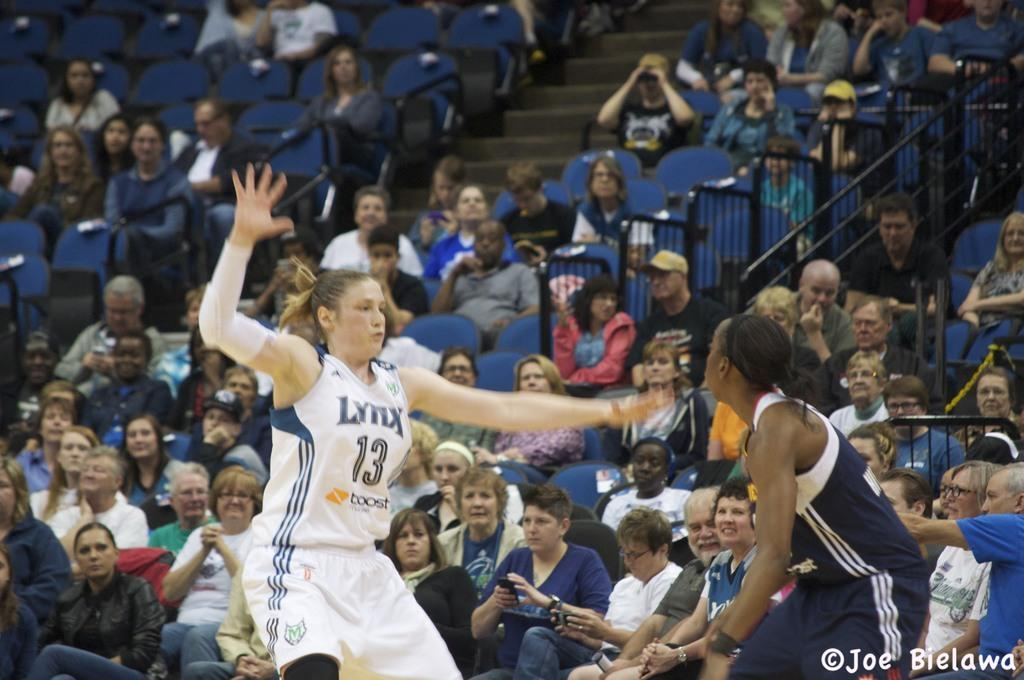What are the people in the image doing? There are people seated on chairs, a woman is jumping, and another woman is standing in the image. Can you describe the positions of the people in the image? Some people are seated, one woman is jumping, and another woman is standing. What is present at the bottom right corner of the image? There is text at the bottom right corner of the image. Can you see any cemetery or playground in the image? No, there is no cemetery or playground present in the image. What type of shoes is the woman wearing, and can you see her toes? The provided facts do not mention any shoes or toes, so we cannot answer this question based on the information given. 